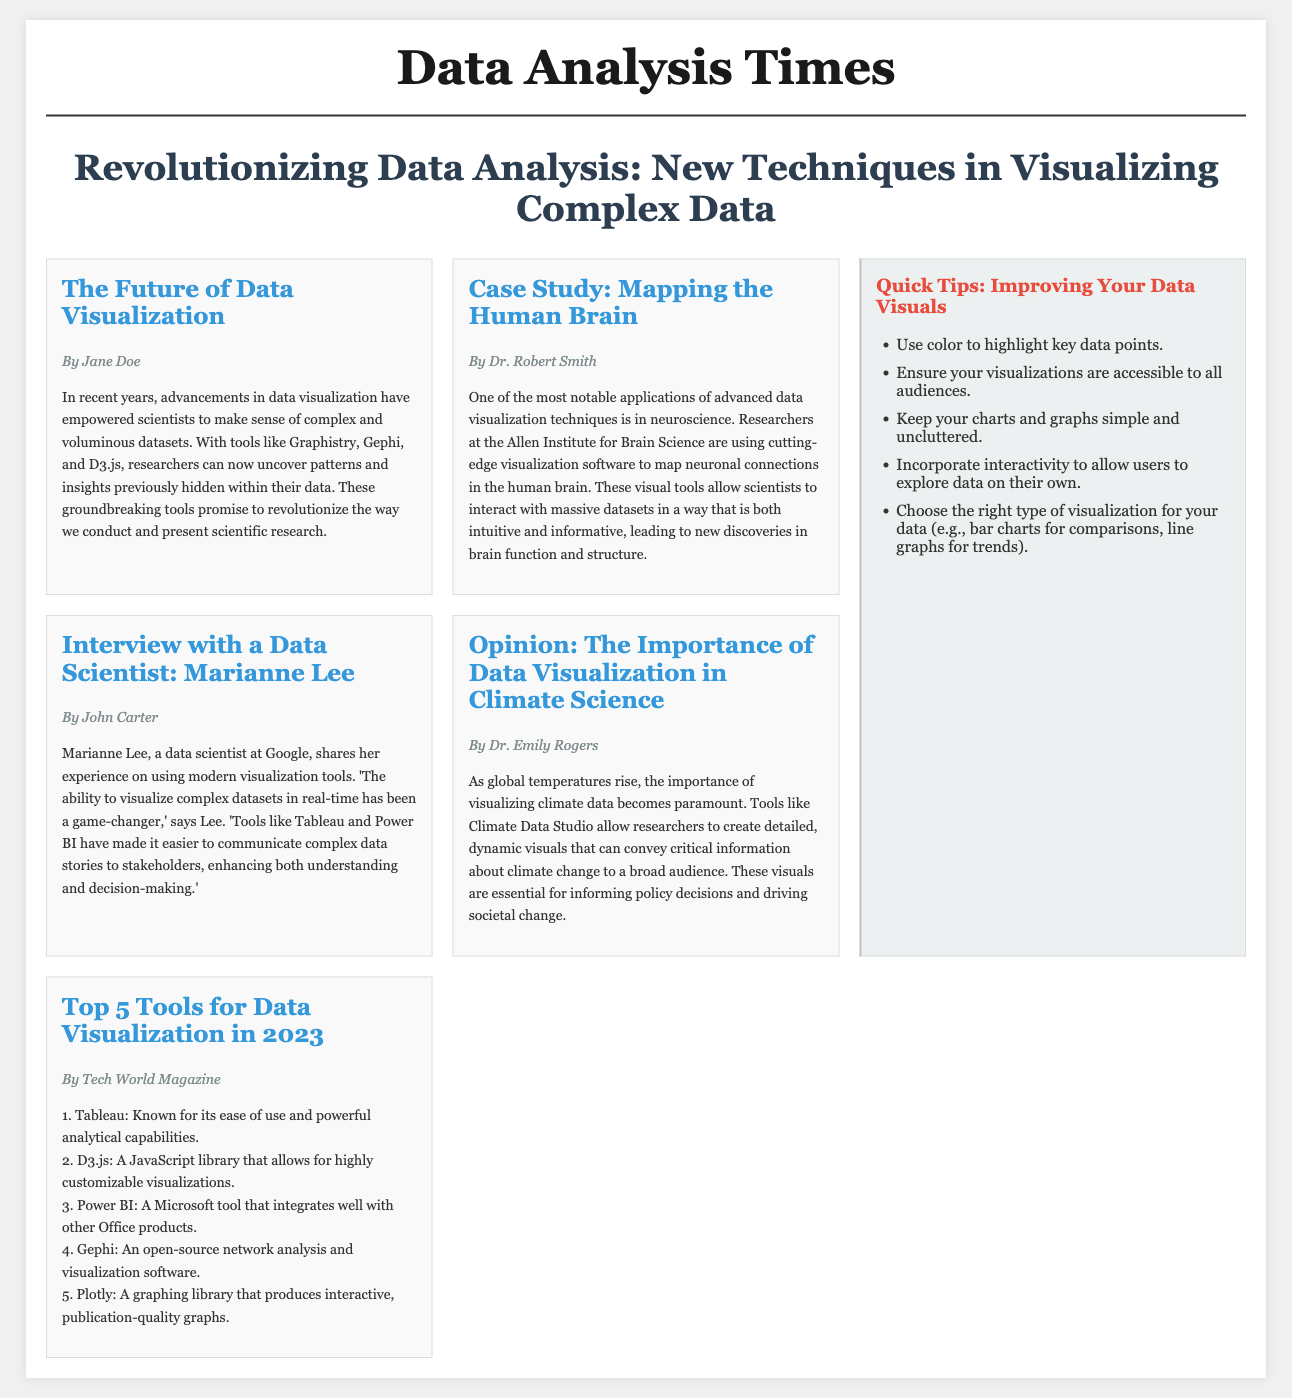What is the title of the main article? The title of the main article is mentioned prominently and summarizes the focus, which is "Revolutionizing Data Analysis: New Techniques in Visualizing Complex Data."
Answer: Revolutionizing Data Analysis: New Techniques in Visualizing Complex Data Who authored the article on mapping the human brain? The author of the article specifically focused on mapping the human brain is mentioned clearly at the beginning of the article.
Answer: Dr. Robert Smith What are the top tools listed for data visualization in 2023? The document enumerates five tools for data visualization in a specific section, which includes Tableau, D3.js, Power BI, Gephi, and Plotly.
Answer: Tableau, D3.js, Power BI, Gephi, Plotly What is one of the key tips for improving data visuals? A quick tip provided in the sidebar emphasizes using color to highlight important aspects within the data visualizations.
Answer: Use color to highlight key data points What is the primary focus of Dr. Emily Rogers' opinion piece? The opinion piece discusses the significance of data visualization in understanding and communicating climate data effectively amid global temperature changes.
Answer: Importance of data visualization in climate science 